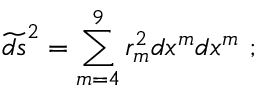Convert formula to latex. <formula><loc_0><loc_0><loc_500><loc_500>\widetilde { d s } ^ { 2 } = \sum _ { m = 4 } ^ { 9 } r _ { m } ^ { 2 } d x ^ { m } d x ^ { m } \ ;</formula> 